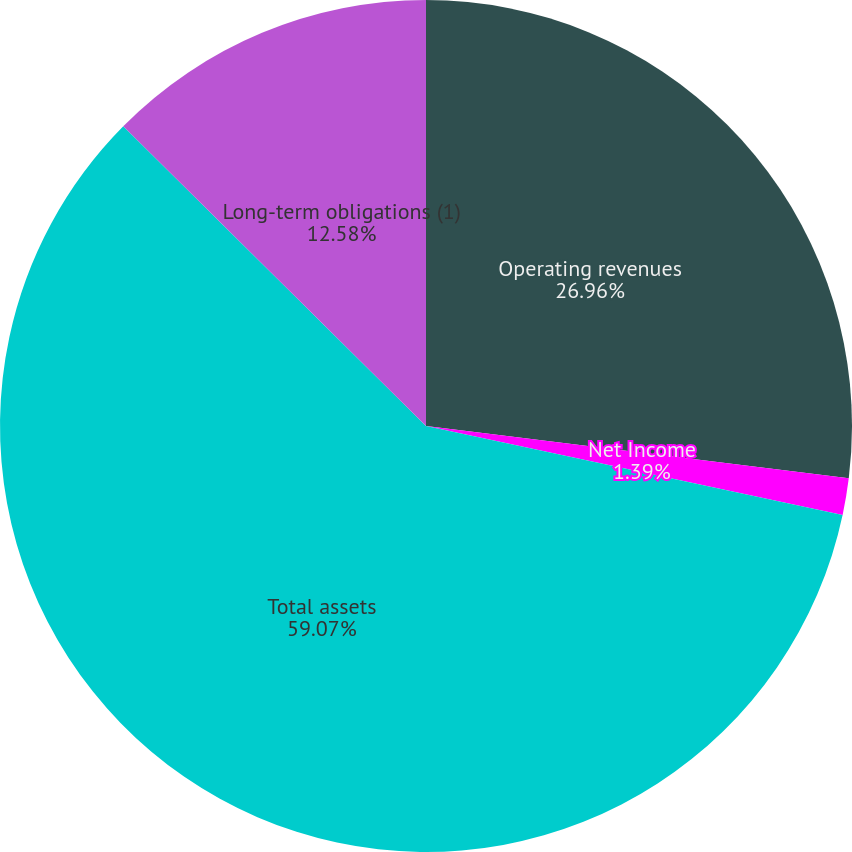Convert chart to OTSL. <chart><loc_0><loc_0><loc_500><loc_500><pie_chart><fcel>Operating revenues<fcel>Net Income<fcel>Total assets<fcel>Long-term obligations (1)<nl><fcel>26.96%<fcel>1.39%<fcel>59.07%<fcel>12.58%<nl></chart> 